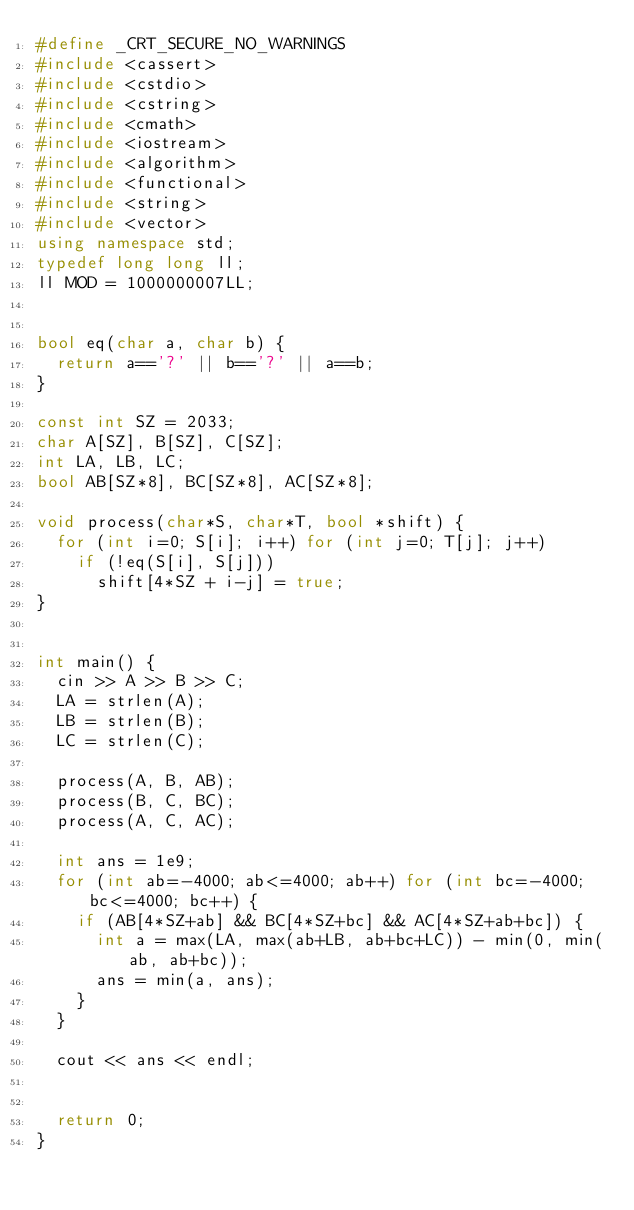<code> <loc_0><loc_0><loc_500><loc_500><_C++_>#define _CRT_SECURE_NO_WARNINGS
#include <cassert>
#include <cstdio>
#include <cstring>
#include <cmath>
#include <iostream>
#include <algorithm>
#include <functional>
#include <string>
#include <vector>
using namespace std;
typedef long long ll;
ll MOD = 1000000007LL;


bool eq(char a, char b) {
	return a=='?' || b=='?' || a==b;
}

const int SZ = 2033;
char A[SZ], B[SZ], C[SZ];
int LA, LB, LC;
bool AB[SZ*8], BC[SZ*8], AC[SZ*8];

void process(char*S, char*T, bool *shift) {
	for (int i=0; S[i]; i++) for (int j=0; T[j]; j++)
		if (!eq(S[i], S[j]))
			shift[4*SZ + i-j] = true;
}


int main() {
	cin >> A >> B >> C;
	LA = strlen(A);
	LB = strlen(B);
	LC = strlen(C);

	process(A, B, AB);
	process(B, C, BC);
	process(A, C, AC);

	int ans = 1e9;
	for (int ab=-4000; ab<=4000; ab++) for (int bc=-4000; bc<=4000; bc++) {
		if (AB[4*SZ+ab] && BC[4*SZ+bc] && AC[4*SZ+ab+bc]) {
			int a = max(LA, max(ab+LB, ab+bc+LC)) - min(0, min(ab, ab+bc));
			ans = min(a, ans);
		}
	}

	cout << ans << endl;


	return 0;
}</code> 